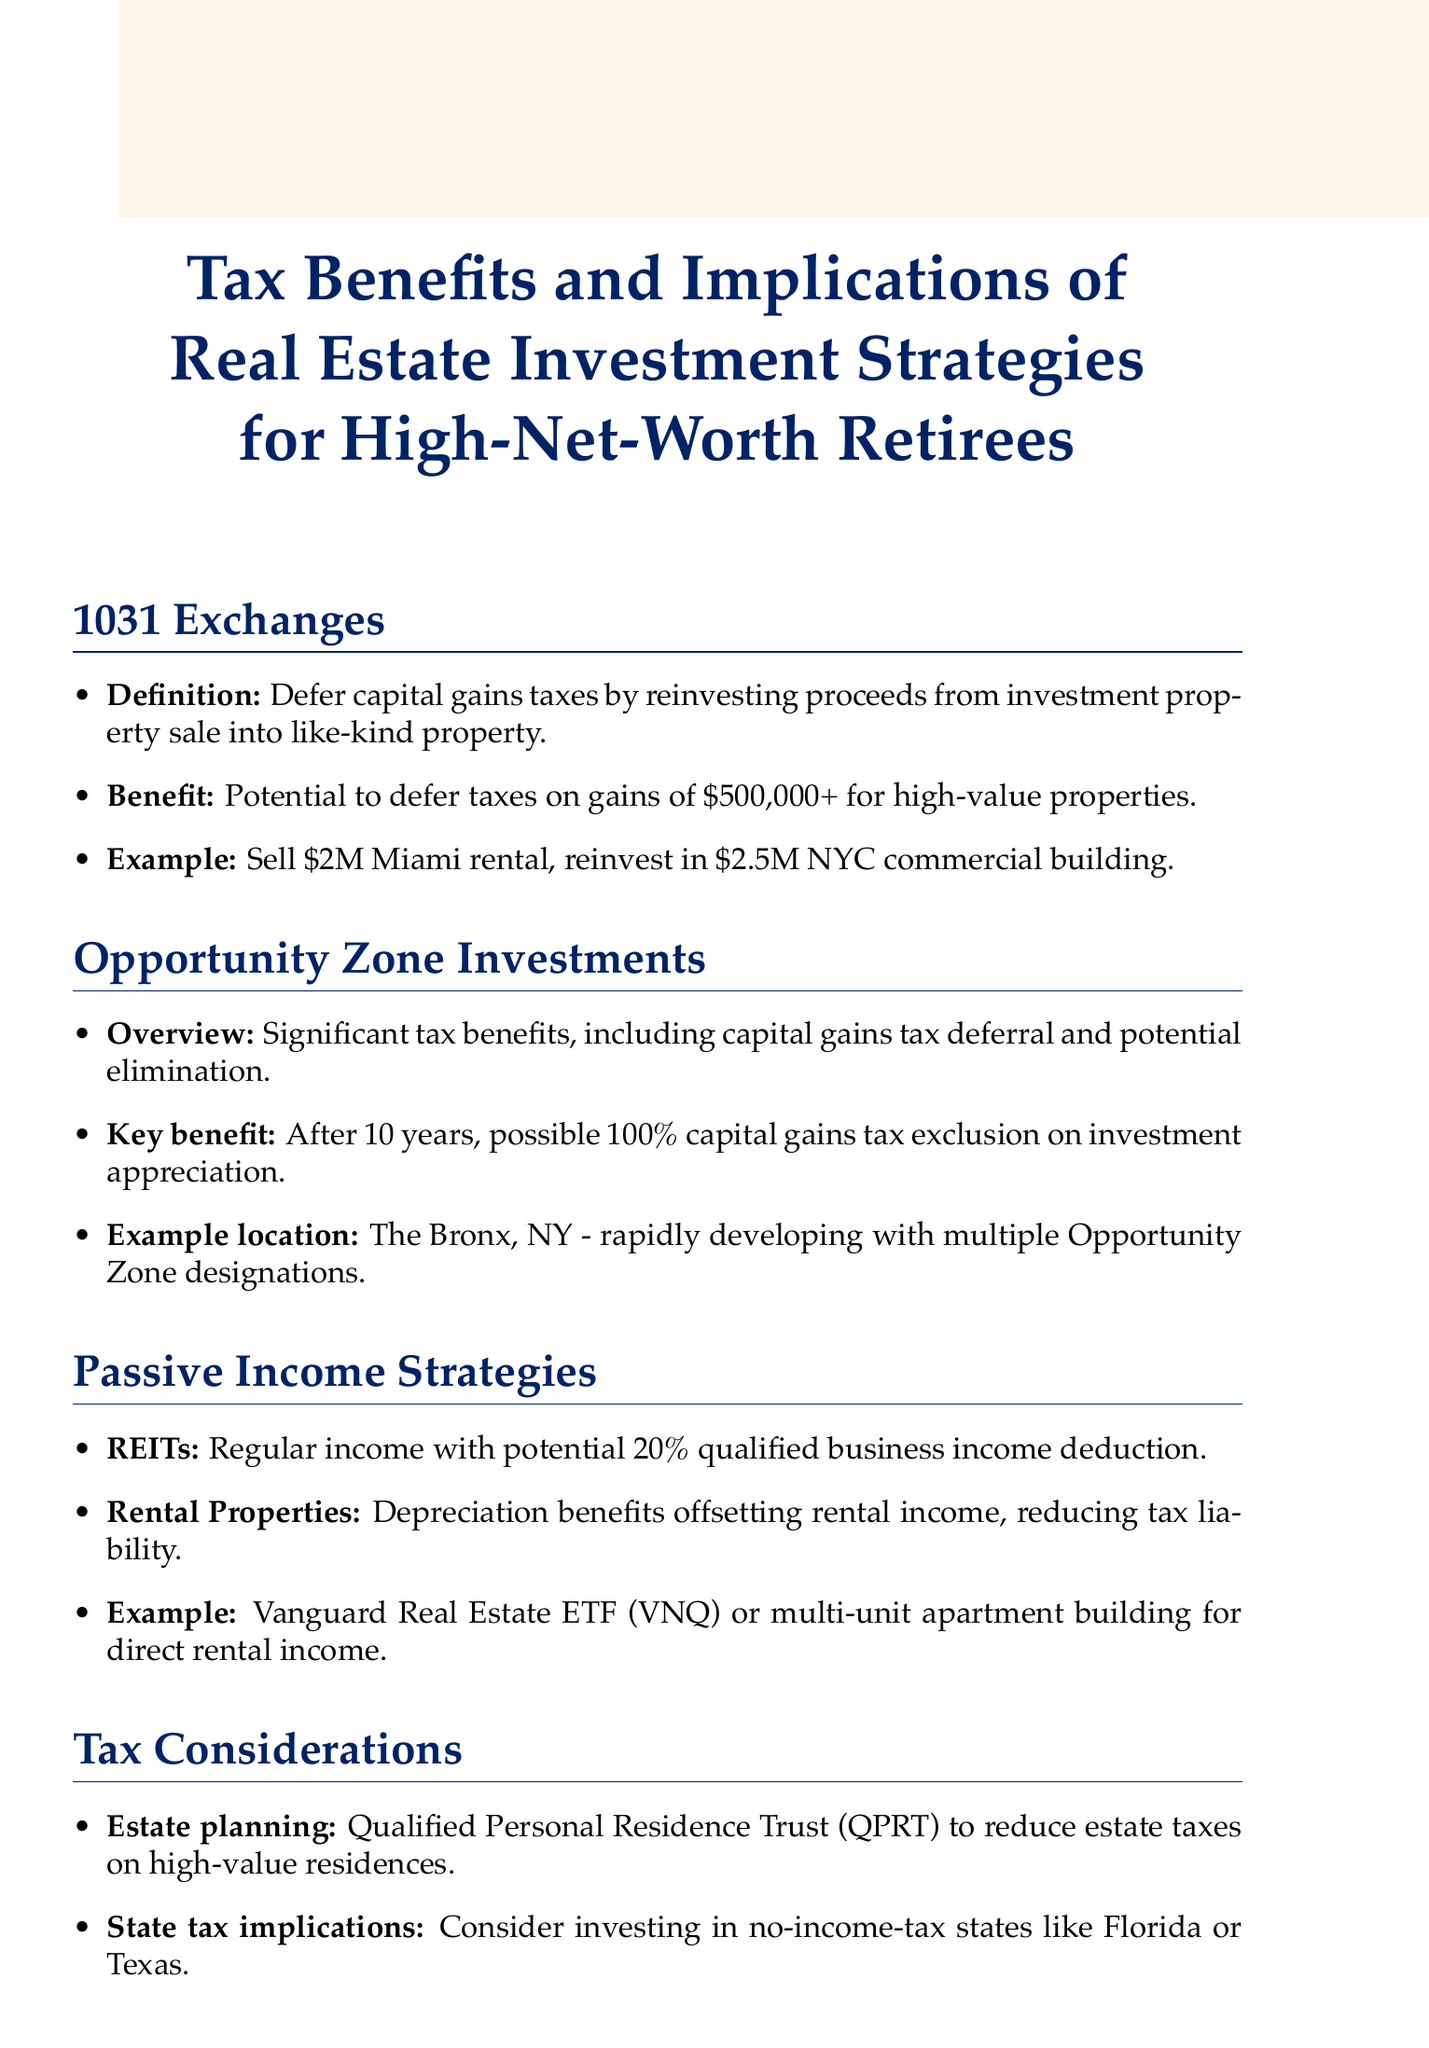What is a 1031 exchange? A 1031 exchange allows investors to defer capital gains taxes by reinvesting proceeds from the sale of an investment property into a like-kind property.
Answer: Deferring capital gains taxes What is the potential capital gains tax deferral period for Opportunity Zone investments? Investors may be eligible for 100% capital gains tax exclusion on the appreciation of their Opportunity Zone investment after 10 years.
Answer: 10 years What investment provides regular income with a potential tax deduction? The document mentions Real Estate Investment Trusts (REITs) as providing regular income streams with potential tax advantages.
Answer: Real Estate Investment Trusts (REITs) What percentage of business income can be deducted with REITs? The document states that REITs offer a potential 20% qualified business income deduction.
Answer: 20% Which state is mentioned as having no income tax? Florida is mentioned as a state with no income tax, maximizing after-tax returns.
Answer: Florida What is the benefit of using a Qualified Personal Residence Trust (QPRT)? Using a QPRT can potentially reduce estate taxes on high-value personal residences.
Answer: Reduce estate taxes What type of trust offers income and significant tax benefits for philanthropically-minded investors? Charitable remainder trusts can provide income while offering significant tax benefits.
Answer: Charitable remainder trusts Which area in New York is highlighted for Opportunity Zone investment? The Bronx, NY, is indicated as a rapidly developing area with multiple Opportunity Zone designations.
Answer: The Bronx, NY How much can investors potentially defer taxes on gains for high-value properties under 1031 exchanges? Investors can defer taxes on gains of $500,000 or more for high-value properties.
Answer: $500,000 or more 